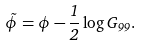Convert formula to latex. <formula><loc_0><loc_0><loc_500><loc_500>\tilde { \phi } = \phi - \frac { 1 } { 2 } \log G _ { 9 9 } .</formula> 